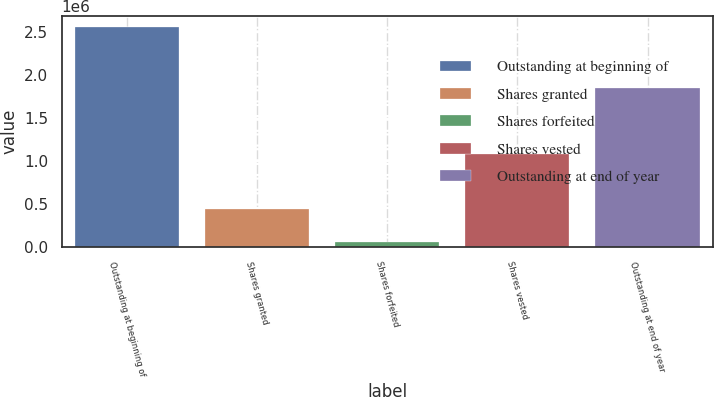Convert chart. <chart><loc_0><loc_0><loc_500><loc_500><bar_chart><fcel>Outstanding at beginning of<fcel>Shares granted<fcel>Shares forfeited<fcel>Shares vested<fcel>Outstanding at end of year<nl><fcel>2.55978e+06<fcel>443060<fcel>63105<fcel>1.08212e+06<fcel>1.85761e+06<nl></chart> 